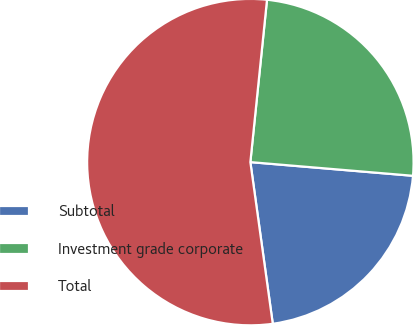<chart> <loc_0><loc_0><loc_500><loc_500><pie_chart><fcel>Subtotal<fcel>Investment grade corporate<fcel>Total<nl><fcel>21.47%<fcel>24.71%<fcel>53.82%<nl></chart> 